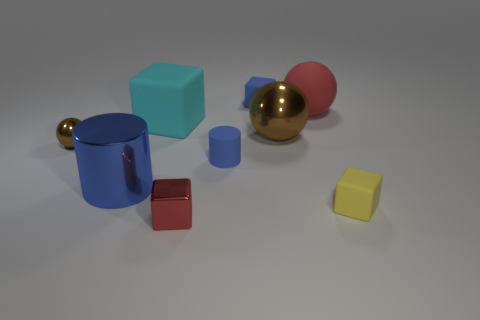How many things are blue objects behind the cyan rubber object or rubber objects that are in front of the small blue matte cylinder?
Give a very brief answer. 2. Is the cyan cube the same size as the rubber cylinder?
Provide a short and direct response. No. Is the number of large blue metallic cylinders greater than the number of metallic objects?
Give a very brief answer. No. How many other objects are the same color as the tiny shiny cube?
Your answer should be very brief. 1. What number of objects are large metal balls or red cubes?
Ensure brevity in your answer.  2. Is the shape of the tiny matte thing that is behind the big red thing the same as  the cyan rubber thing?
Your answer should be compact. Yes. What is the color of the shiny ball behind the brown metallic sphere on the left side of the blue matte cube?
Give a very brief answer. Brown. Are there fewer cubes than yellow objects?
Make the answer very short. No. Are there any blue balls made of the same material as the big block?
Your answer should be very brief. No. There is a large blue shiny object; is its shape the same as the blue rubber thing behind the big red thing?
Keep it short and to the point. No. 